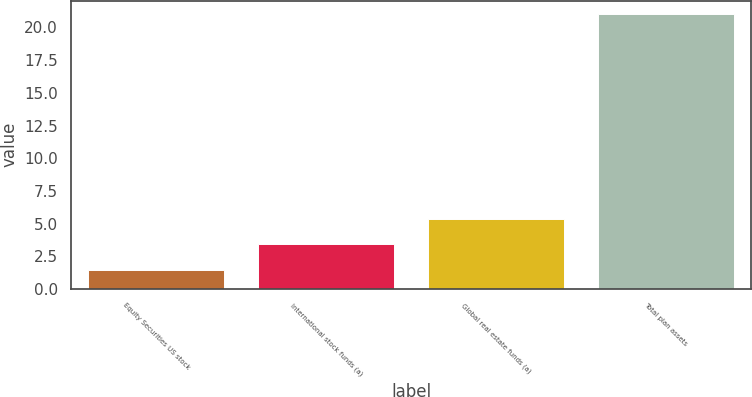Convert chart to OTSL. <chart><loc_0><loc_0><loc_500><loc_500><bar_chart><fcel>Equity Securities US stock<fcel>International stock funds (a)<fcel>Global real estate funds (a)<fcel>Total plan assets<nl><fcel>1.44<fcel>3.4<fcel>5.36<fcel>21<nl></chart> 